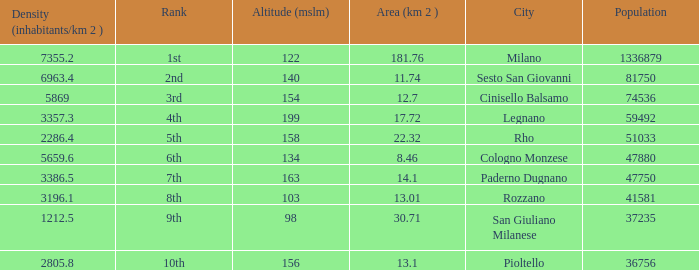Which Population is the highest one that has a Density (inhabitants/km 2) larger than 2805.8, and a Rank of 1st, and an Altitude (mslm) smaller than 122? None. 